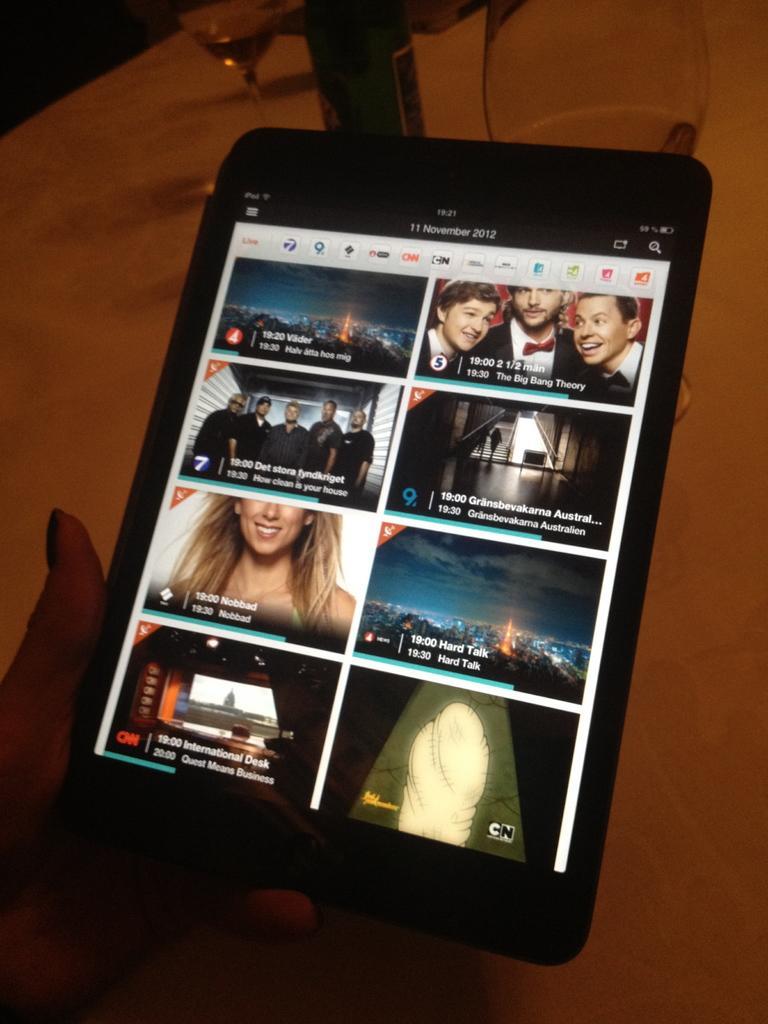Could you give a brief overview of what you see in this image? In this picture I can see a person's hand who is holding a tablet and I see few pictures on the screen and I see something is written. In the background I can see the brown color surface and on top of this picture I can see 2 glasses. 